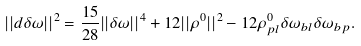Convert formula to latex. <formula><loc_0><loc_0><loc_500><loc_500>| | d \delta \omega | | ^ { 2 } = \frac { 1 5 } { 2 8 } | | \delta \omega | | ^ { 4 } + 1 2 | | \rho ^ { 0 } | | ^ { 2 } - 1 2 \rho ^ { 0 } _ { p l } \delta \omega _ { b l } \delta \omega _ { b p } .</formula> 